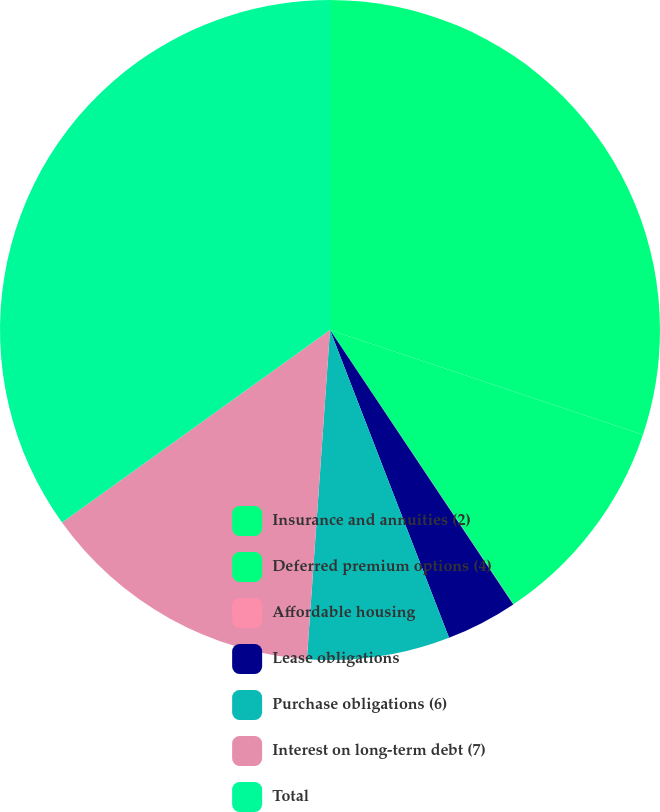<chart> <loc_0><loc_0><loc_500><loc_500><pie_chart><fcel>Insurance and annuities (2)<fcel>Deferred premium options (4)<fcel>Affordable housing<fcel>Lease obligations<fcel>Purchase obligations (6)<fcel>Interest on long-term debt (7)<fcel>Total<nl><fcel>30.14%<fcel>10.48%<fcel>0.01%<fcel>3.5%<fcel>6.99%<fcel>13.97%<fcel>34.92%<nl></chart> 